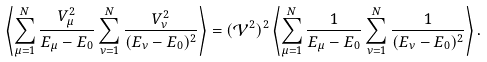Convert formula to latex. <formula><loc_0><loc_0><loc_500><loc_500>\left \langle \sum _ { \mu = 1 } ^ { N } \frac { V _ { \mu } ^ { 2 } } { E _ { \mu } - E _ { 0 } } \sum _ { \nu = 1 } ^ { N } \frac { V _ { \nu } ^ { 2 } } { ( E _ { \nu } - E _ { 0 } ) ^ { 2 } } \right \rangle = ( { \mathcal { V } } ^ { 2 } ) ^ { 2 } \left \langle \sum _ { \mu = 1 } ^ { N } \frac { 1 } { E _ { \mu } - E _ { 0 } } \sum _ { \nu = 1 } ^ { N } \frac { 1 } { ( E _ { \nu } - E _ { 0 } ) ^ { 2 } } \right \rangle .</formula> 